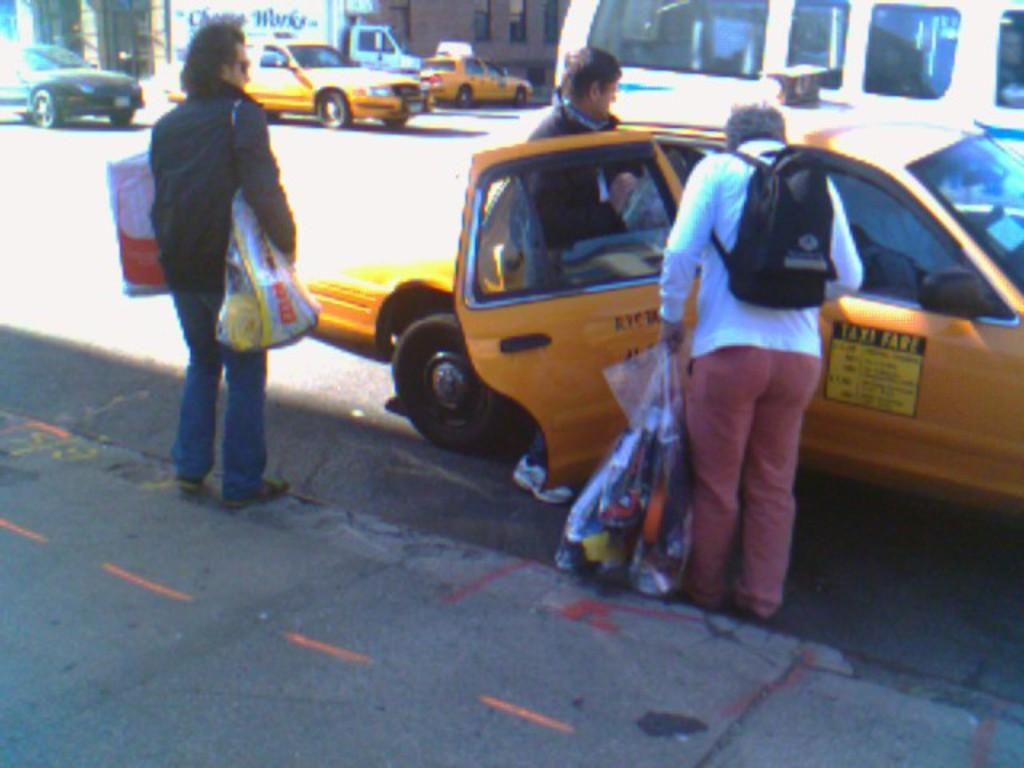How many people are in the image? There are people in the image, but the exact number is not specified. What are the people holding in the image? The people are holding bags in the image. What can be observed about the clothing of the people in the image? The people are wearing different color dresses in the image. What can be seen on the road in the image? There are vehicles visible on the road in the image. What is visible in the background of the image? There is a building in the background of the image, and it has windows. What type of steel is used in the construction of the building in the image? There is no information about the type of steel used in the construction of the building in the image. What is the temperature of the temper in the image? There is no mention of temper or temperature in the image. 